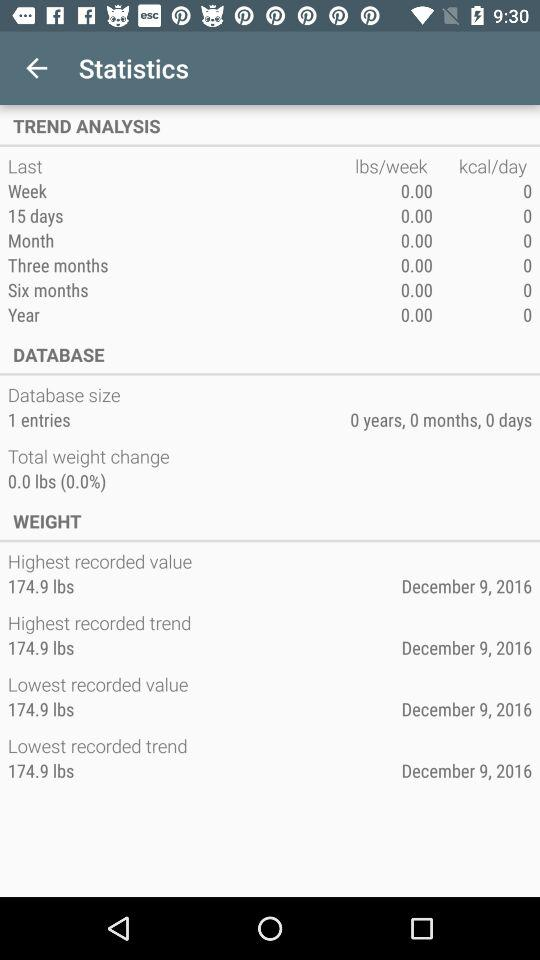What is the total change in weight? The total change in weight is 0.0 lbs. 